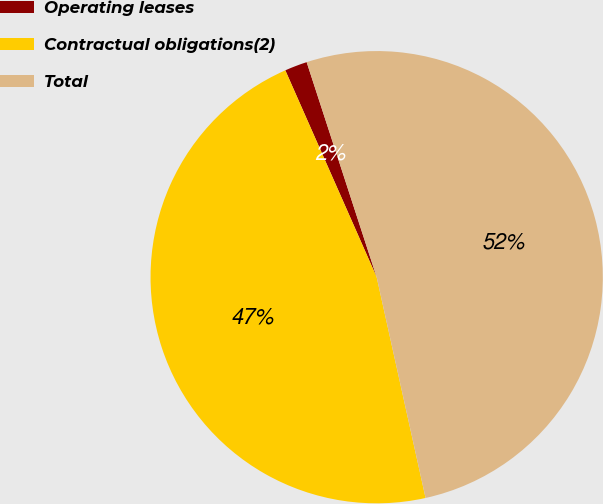Convert chart to OTSL. <chart><loc_0><loc_0><loc_500><loc_500><pie_chart><fcel>Operating leases<fcel>Contractual obligations(2)<fcel>Total<nl><fcel>1.61%<fcel>46.85%<fcel>51.54%<nl></chart> 